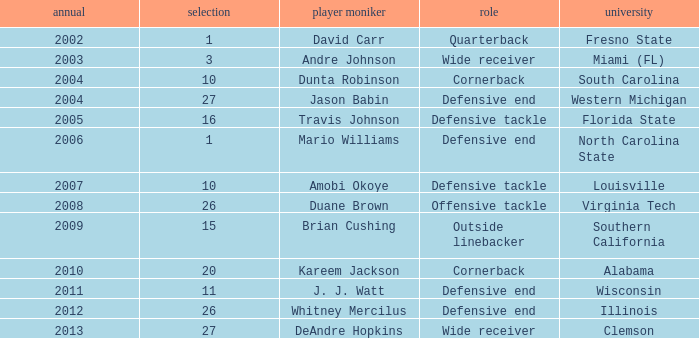What pick was mario williams before 2006? None. 